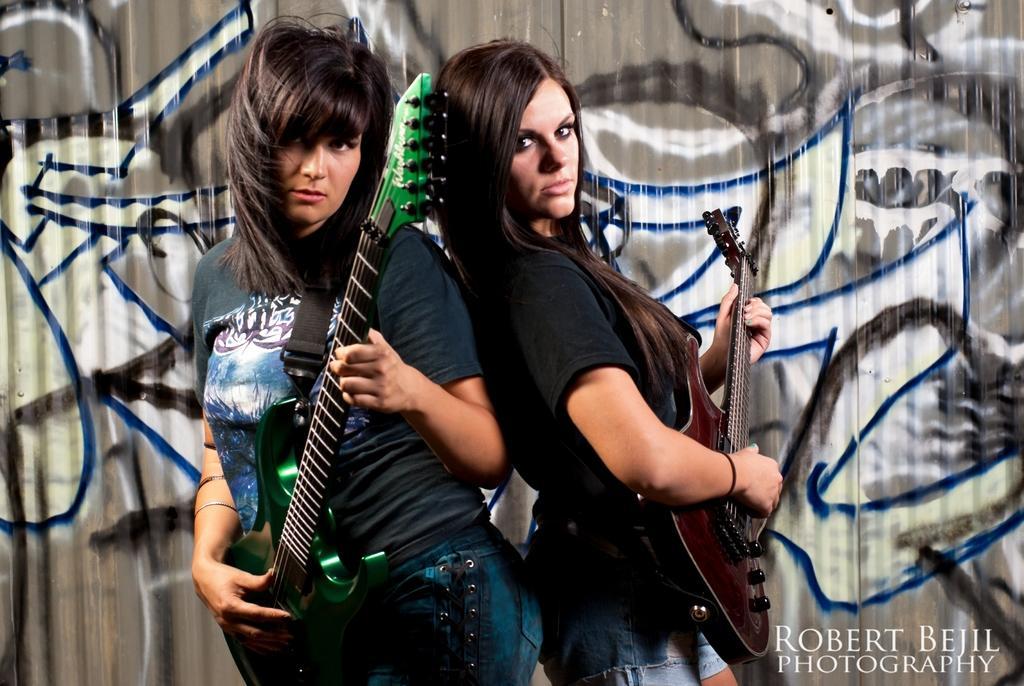Please provide a concise description of this image. this is the picture of of a two women holding a guitar and standing on the stage. Behind the women's there's a wall and the wall is painted. 